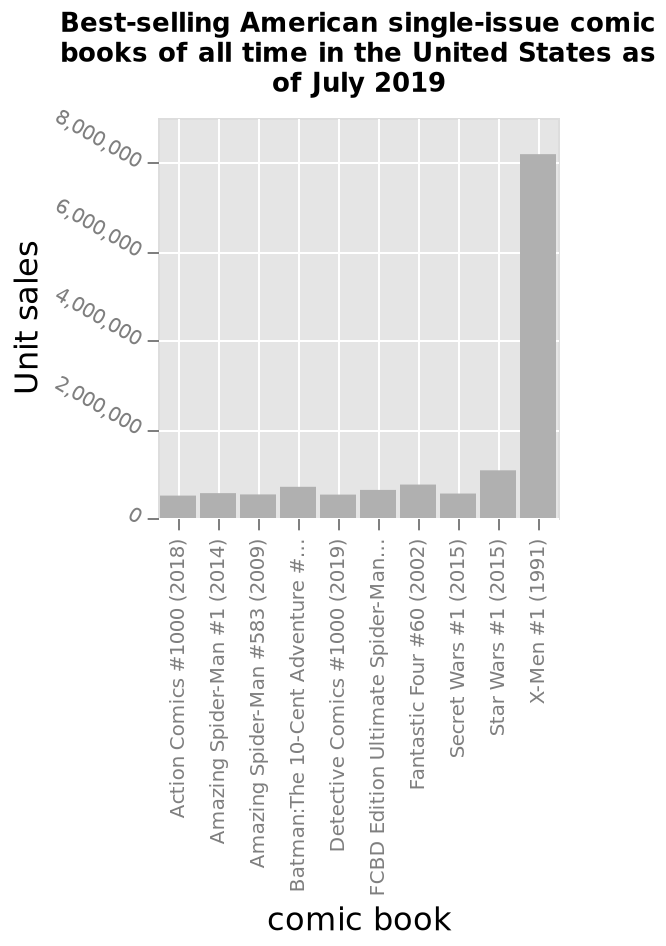<image>
please enumerates aspects of the construction of the chart Best-selling American single-issue comic books of all time in the United States as of July 2019 is a bar plot. On the x-axis, comic book is measured using a categorical scale starting with Action Comics #1000 (2018) and ending with X-Men #1 (1991). On the y-axis, Unit sales is defined. What was the sales difference between X Men and other magazines? X Men sold significantly more copies, with a difference of well over 6 million copies compared to other magazines. 